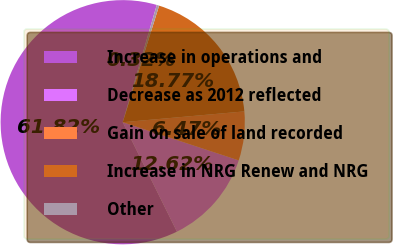Convert chart to OTSL. <chart><loc_0><loc_0><loc_500><loc_500><pie_chart><fcel>Increase in operations and<fcel>Decrease as 2012 reflected<fcel>Gain on sale of land recorded<fcel>Increase in NRG Renew and NRG<fcel>Other<nl><fcel>61.82%<fcel>12.62%<fcel>6.47%<fcel>18.77%<fcel>0.32%<nl></chart> 